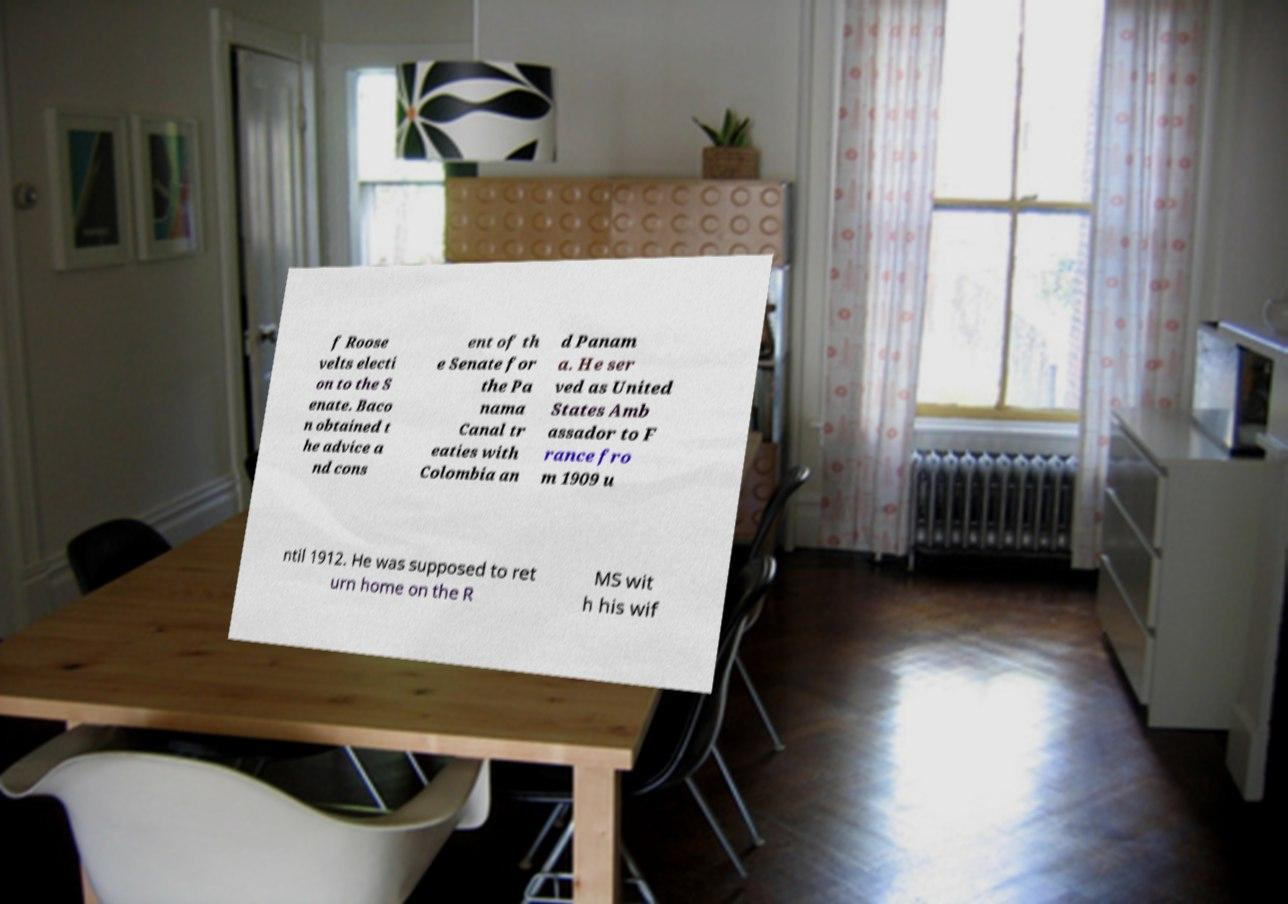Could you extract and type out the text from this image? f Roose velts electi on to the S enate. Baco n obtained t he advice a nd cons ent of th e Senate for the Pa nama Canal tr eaties with Colombia an d Panam a. He ser ved as United States Amb assador to F rance fro m 1909 u ntil 1912. He was supposed to ret urn home on the R MS wit h his wif 